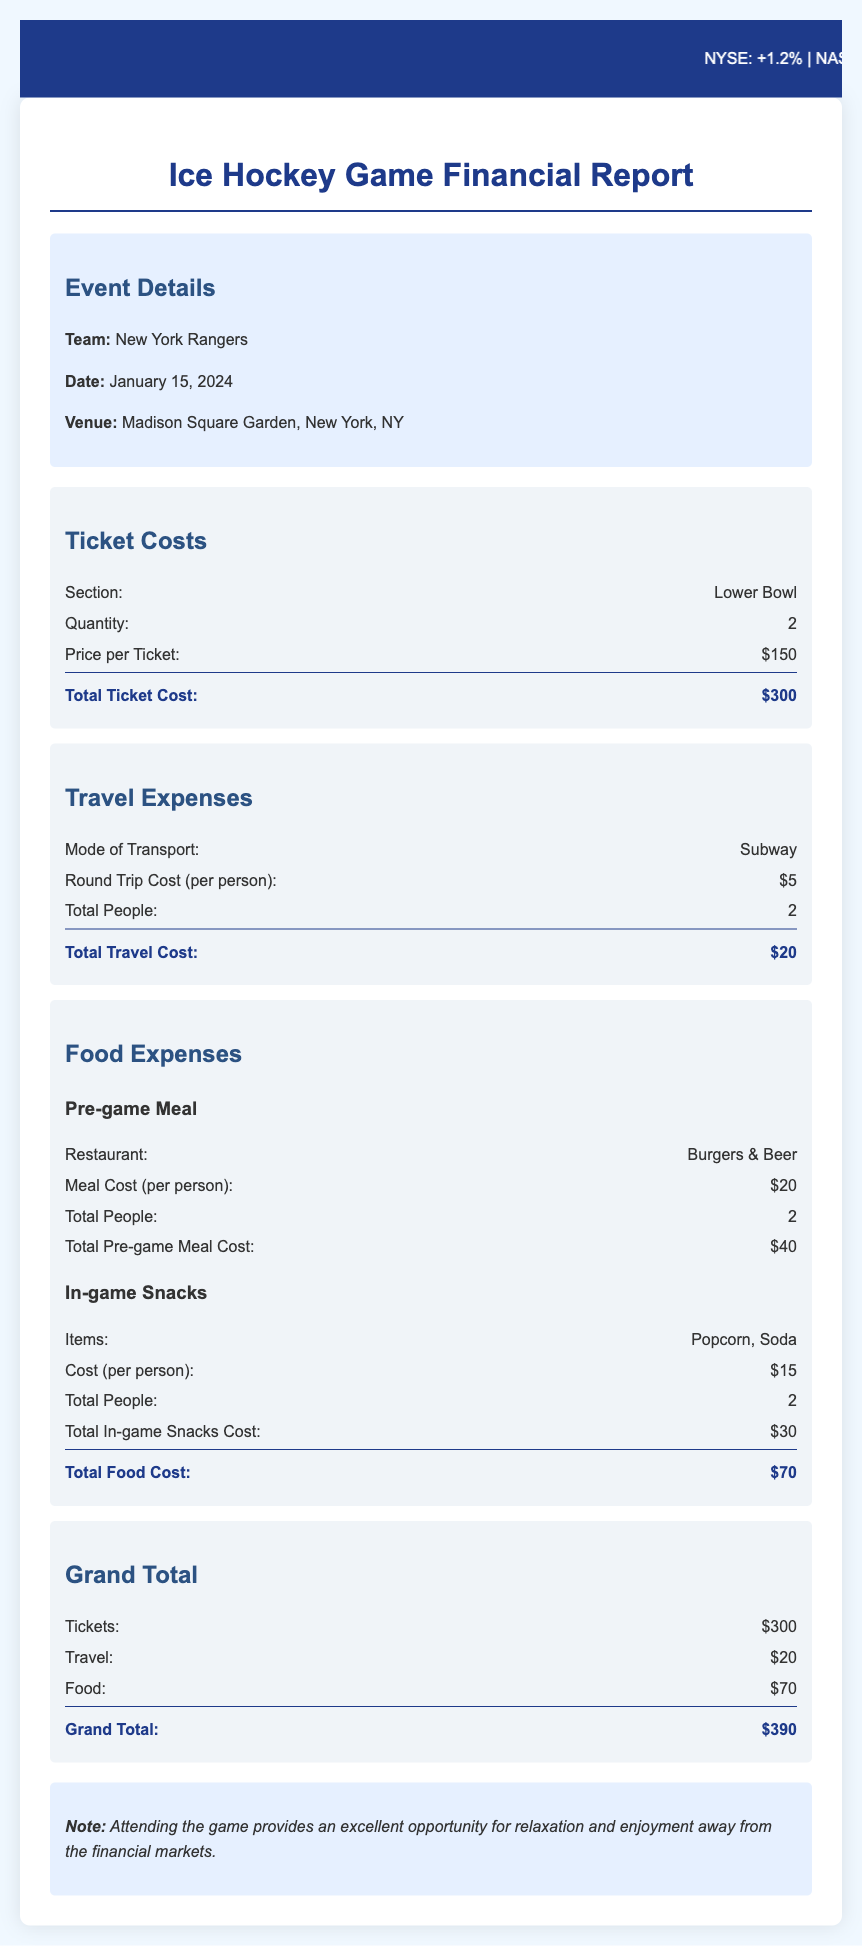What is the total ticket cost? The total ticket cost is calculated by multiplying the quantity of tickets by the price per ticket: 2 x $150 = $300.
Answer: $300 How much does it cost to travel per person? The round trip cost for travel per person is listed in the document and is $5.
Answer: $5 What is the total food expense? The total food expense includes the costs for pre-game meals and in-game snacks, which totals $70.
Answer: $70 How many tickets were purchased? The quantity of tickets purchased is specified in the document as 2.
Answer: 2 What is the venue for the game? The venue where the ice hockey game will be held is Madison Square Garden, as noted in the document.
Answer: Madison Square Garden What is the grand total cost for attending the game? The grand total is calculated by summing up the ticket, travel, and food costs: $300 + $20 + $70 = $390.
Answer: $390 How many people are attending the game? The total number of people attending the game, as noted in the expenses, is 2.
Answer: 2 Which team is playing? The team that is playing in the game is the New York Rangers, mentioned in the event details.
Answer: New York Rangers What is the name of the restaurant for the pre-game meal? The restaurant where the pre-game meal is scheduled is called Burgers & Beer.
Answer: Burgers & Beer 